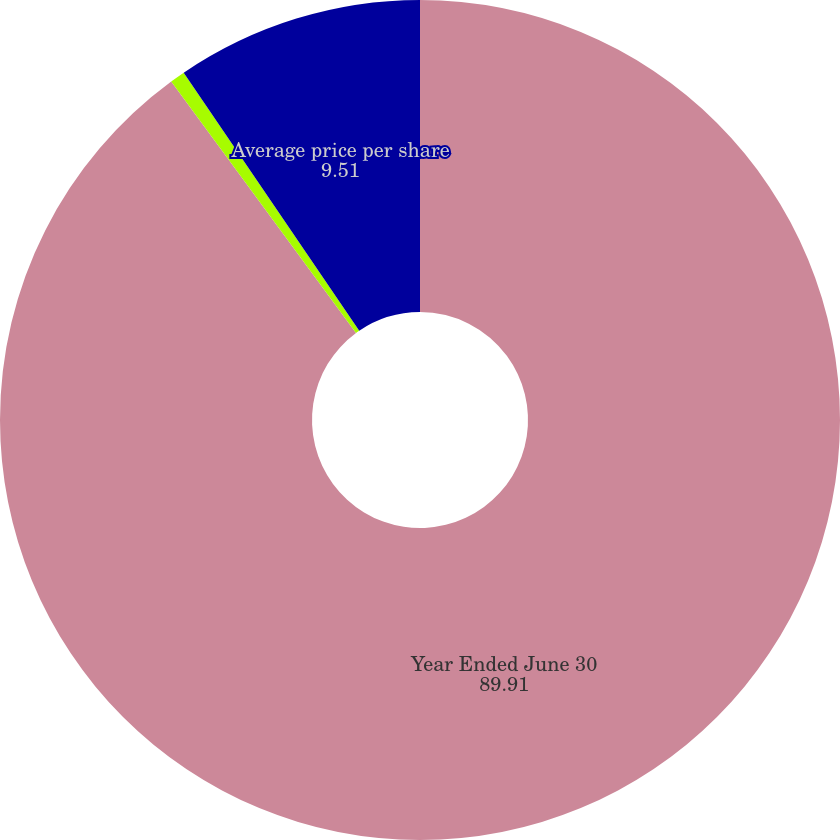Convert chart to OTSL. <chart><loc_0><loc_0><loc_500><loc_500><pie_chart><fcel>Year Ended June 30<fcel>Shares purchased<fcel>Average price per share<nl><fcel>89.91%<fcel>0.58%<fcel>9.51%<nl></chart> 